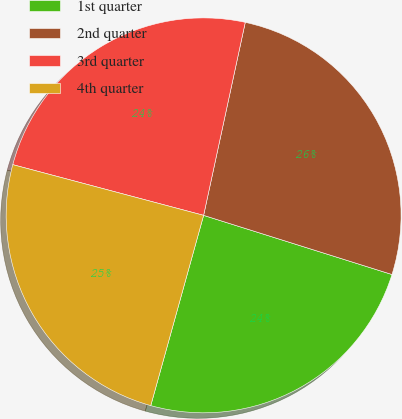Convert chart to OTSL. <chart><loc_0><loc_0><loc_500><loc_500><pie_chart><fcel>1st quarter<fcel>2nd quarter<fcel>3rd quarter<fcel>4th quarter<nl><fcel>24.47%<fcel>26.46%<fcel>24.25%<fcel>24.82%<nl></chart> 